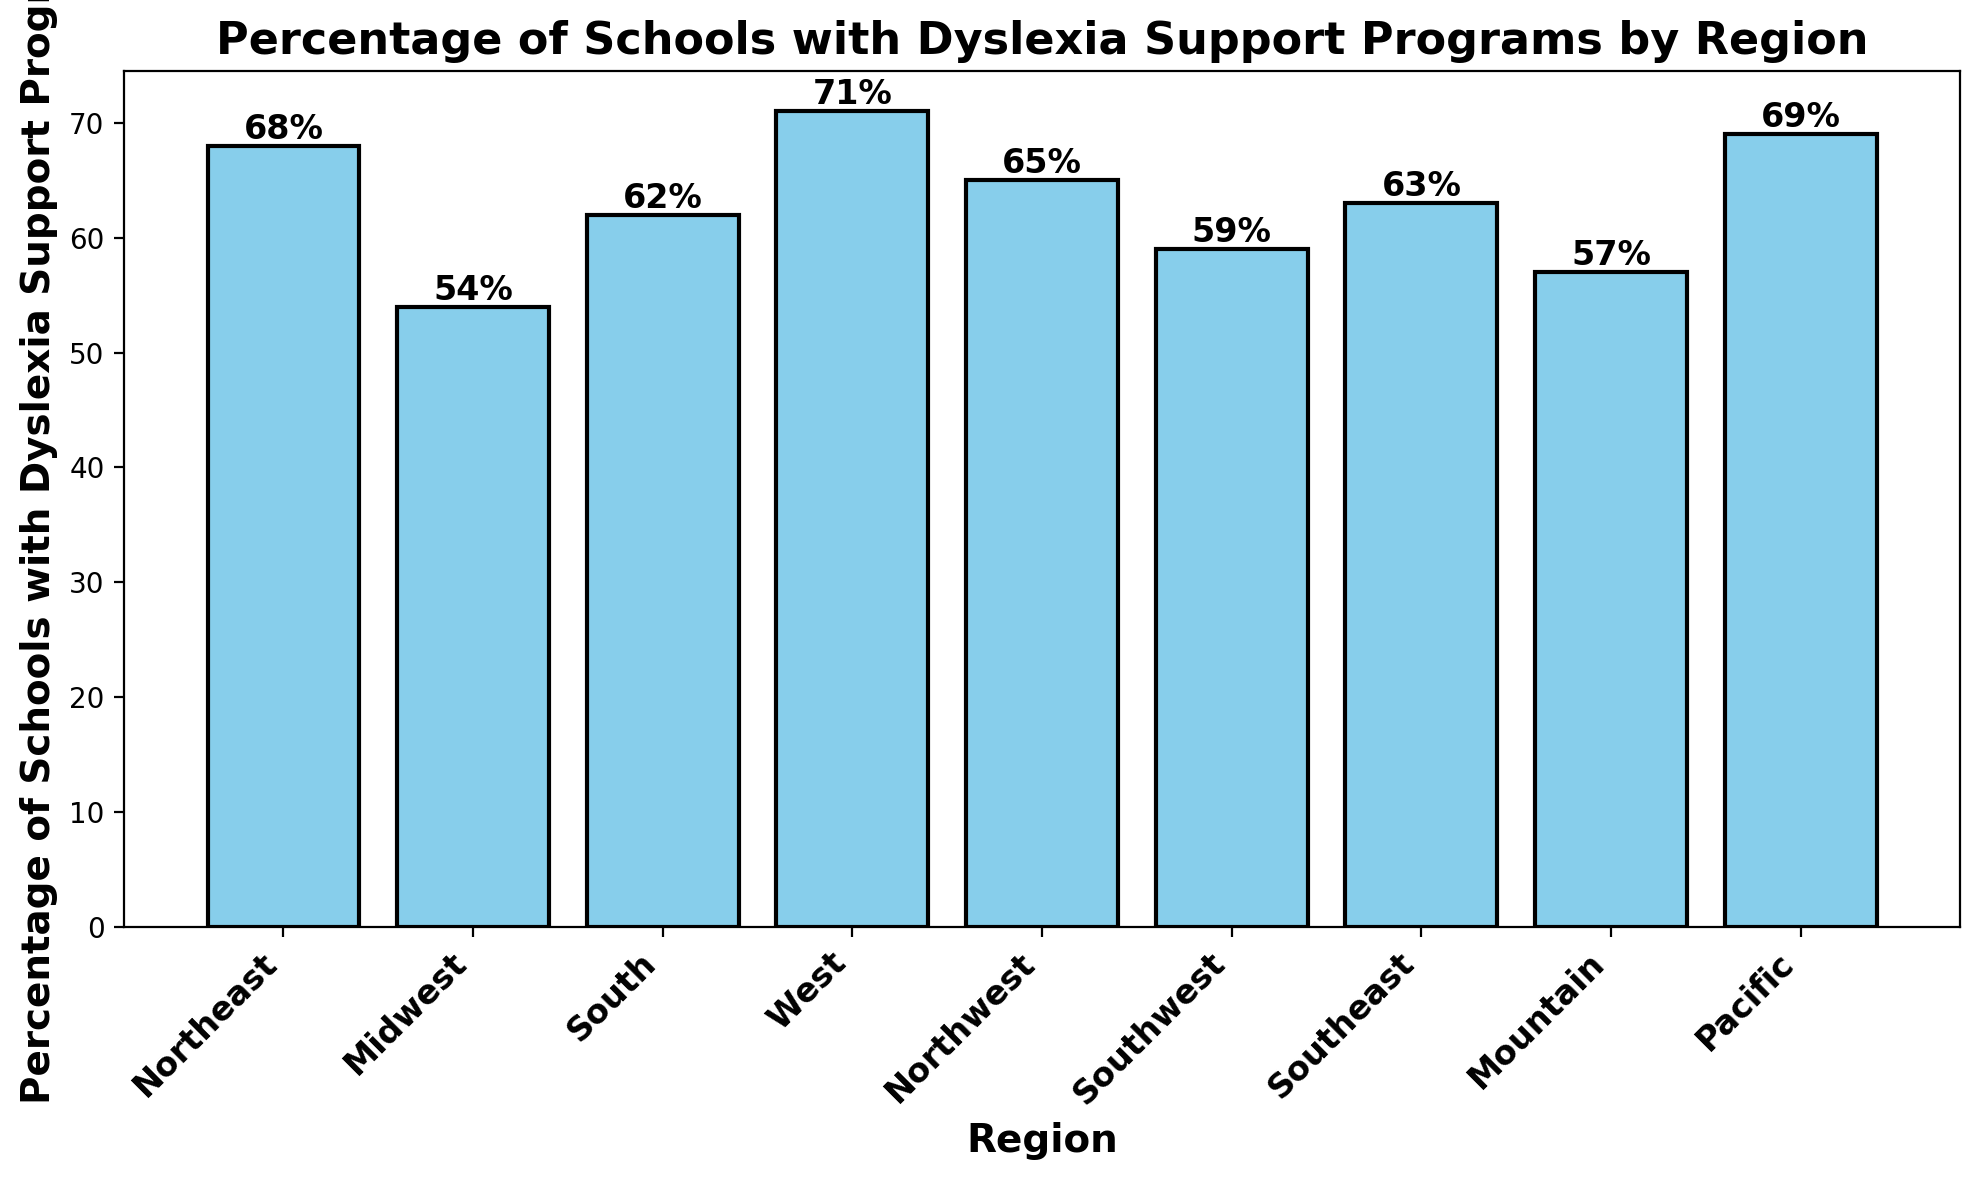Which region has the highest percentage of schools with dyslexia support programs? The highest bar corresponds to the West region, indicating the highest percentage.
Answer: West Which two regions have nearly the same percentage of schools with dyslexia support programs? The Northeast and Pacific regions have very close percentages, with the Northeast at 68% and the Pacific at 69%.
Answer: Northeast and Pacific What is the difference in the percentage of schools with dyslexia support programs between the Midwest and the Southeast? The Midwest has 54% and the Southeast has 63%. The difference is calculated as 63% - 54%.
Answer: 9% What's the average percentage of schools with dyslexia support programs in the Northeast, South, and Southeast regions? Add the percentages for these regions: 68% (Northeast) + 62% (South) + 63% (Southeast) = 193%, then divide by 3.
Answer: 64.33% Which region has the lowest percentage of schools with dyslexia support programs? The lowest bar corresponds to the Midwest region, indicating the lowest percentage.
Answer: Midwest Is the percentage of schools with dyslexia support programs in the Southwest higher or lower than the national average (use the given data's regions as the national average)? First, calculate the national average: (68 + 54 + 62 + 71 + 65 + 59 + 63 + 57 + 69) / 9, which is 63.11%. The Southwest has 59%, which is lower.
Answer: Lower How many regions have a percentage of schools with dyslexia support programs above 65%? The regions with percentages above 65% are West (71%), Northeast (68%), and Pacific (69%). This makes a total of 3 regions.
Answer: 3 What is the combined percentage of schools with dyslexia support programs in the Northwest and Mountain regions? Add the percentages for these regions: Northwest (65%) + Mountain (57%) = 122%.
Answer: 122% Compare the percentage difference between the South and Southeast region. Is it significant? The South has 62% and the Southeast has 63%. The difference is calculated as 63% - 62%, which results in 1%. This is not a significant difference.
Answer: Not significant Which region stands out visually due to its bar reaching above 70%? The West region stands out, as its bar height exceeds 70%.
Answer: West 